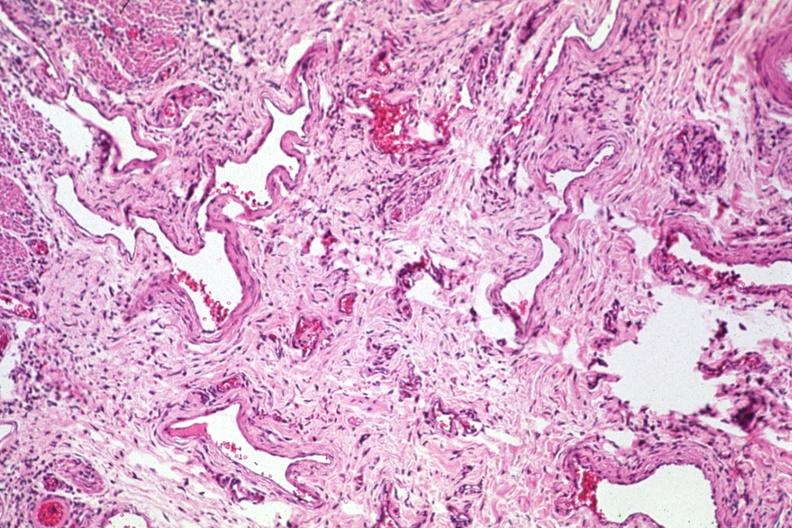s normal palmar creases present?
Answer the question using a single word or phrase. No 